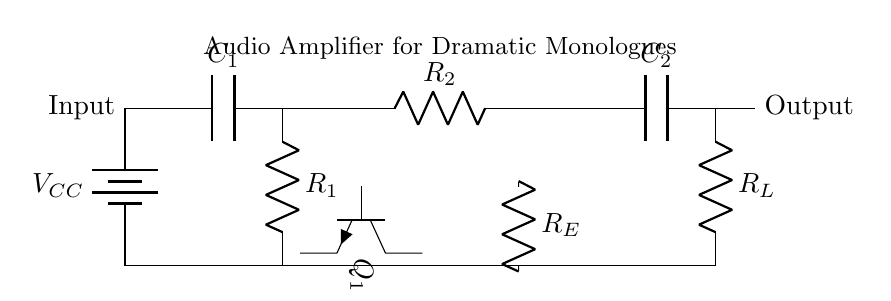What is the function of capacitor C1? Capacitor C1 is used for coupling, which allows the AC audio signal to pass while blocking any DC component. This is essential for amplifying audio signals without DC offset interference.
Answer: Coupling What type of transistor is Q1? Q1 is an NPN transistor, as indicated by the symbol and the orientation of the terminals. This type is commonly used for amplifying signals in audio applications.
Answer: NPN What is the role of resistor R_E? Resistor R_E serves as an emitter resistor, providing stability to the operating point of the transistor and improving linearity in the amplification process.
Answer: Emitter resistor What is the output voltage relative to the input voltage? The output voltage is typically higher than the input voltage due to the amplification process. In this circuit, the gain can vary depending on the configuration of the components, specifically the resistor values.
Answer: Higher How does capacitor C2 affect the output signal? Capacitor C2 acts as a coupling capacitor to block any DC component at the output, ensuring that only the AC audio signal is passed to the load, such as speakers.
Answer: Blocks DC What is the supply voltage labeled as in the circuit? The supply voltage is labeled as V_C_C, which stands for the collector supply voltage required for the transistor to operate efficiently.
Answer: V_C_C Which component provides the load in this circuit? The load in this circuit is provided by resistor R_L, which represents the impedance seen by the amplifier during operation.
Answer: R_L 